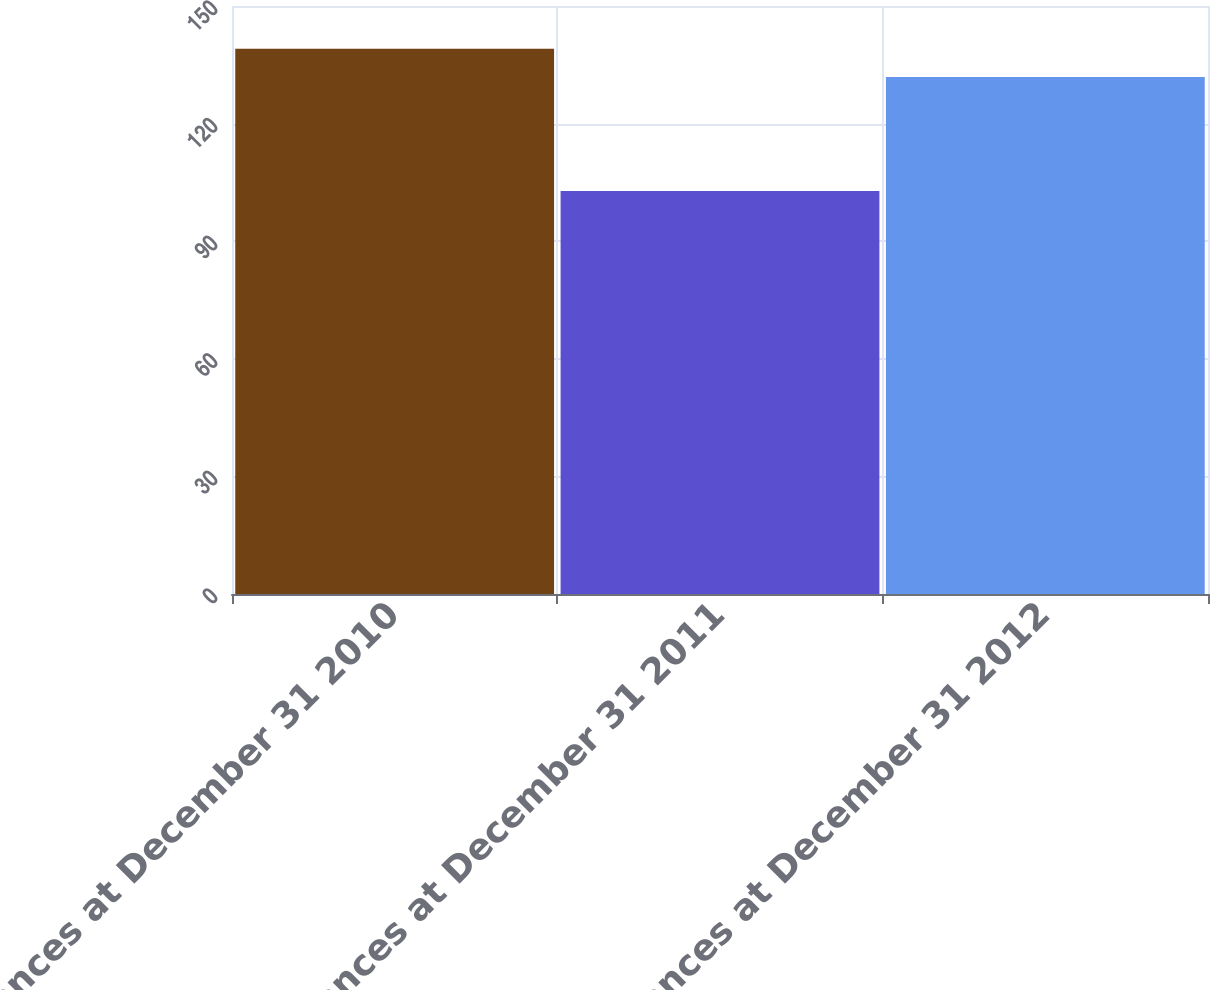Convert chart to OTSL. <chart><loc_0><loc_0><loc_500><loc_500><bar_chart><fcel>Balances at December 31 2010<fcel>Balances at December 31 2011<fcel>Balances at December 31 2012<nl><fcel>139.1<fcel>102.8<fcel>131.9<nl></chart> 